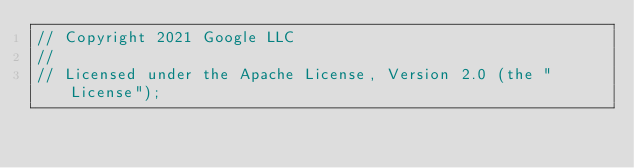Convert code to text. <code><loc_0><loc_0><loc_500><loc_500><_Go_>// Copyright 2021 Google LLC
//
// Licensed under the Apache License, Version 2.0 (the "License");</code> 